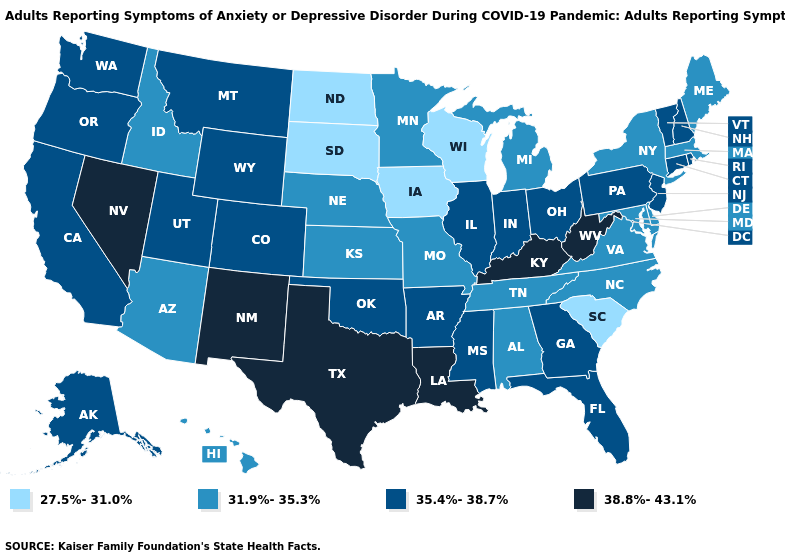Does the first symbol in the legend represent the smallest category?
Write a very short answer. Yes. What is the value of South Carolina?
Keep it brief. 27.5%-31.0%. What is the value of North Dakota?
Answer briefly. 27.5%-31.0%. What is the value of Delaware?
Keep it brief. 31.9%-35.3%. What is the lowest value in the South?
Give a very brief answer. 27.5%-31.0%. Name the states that have a value in the range 27.5%-31.0%?
Be succinct. Iowa, North Dakota, South Carolina, South Dakota, Wisconsin. Name the states that have a value in the range 27.5%-31.0%?
Be succinct. Iowa, North Dakota, South Carolina, South Dakota, Wisconsin. Does Nevada have the highest value in the West?
Concise answer only. Yes. Among the states that border North Dakota , does Montana have the lowest value?
Answer briefly. No. How many symbols are there in the legend?
Quick response, please. 4. What is the value of New Hampshire?
Short answer required. 35.4%-38.7%. Name the states that have a value in the range 38.8%-43.1%?
Write a very short answer. Kentucky, Louisiana, Nevada, New Mexico, Texas, West Virginia. Name the states that have a value in the range 35.4%-38.7%?
Answer briefly. Alaska, Arkansas, California, Colorado, Connecticut, Florida, Georgia, Illinois, Indiana, Mississippi, Montana, New Hampshire, New Jersey, Ohio, Oklahoma, Oregon, Pennsylvania, Rhode Island, Utah, Vermont, Washington, Wyoming. Does Oklahoma have a higher value than West Virginia?
Write a very short answer. No. Which states have the lowest value in the Northeast?
Be succinct. Maine, Massachusetts, New York. 